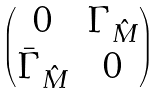<formula> <loc_0><loc_0><loc_500><loc_500>\begin{pmatrix} 0 & \Gamma _ { \hat { M } } \\ \bar { \Gamma } _ { \hat { M } } & 0 \end{pmatrix}</formula> 